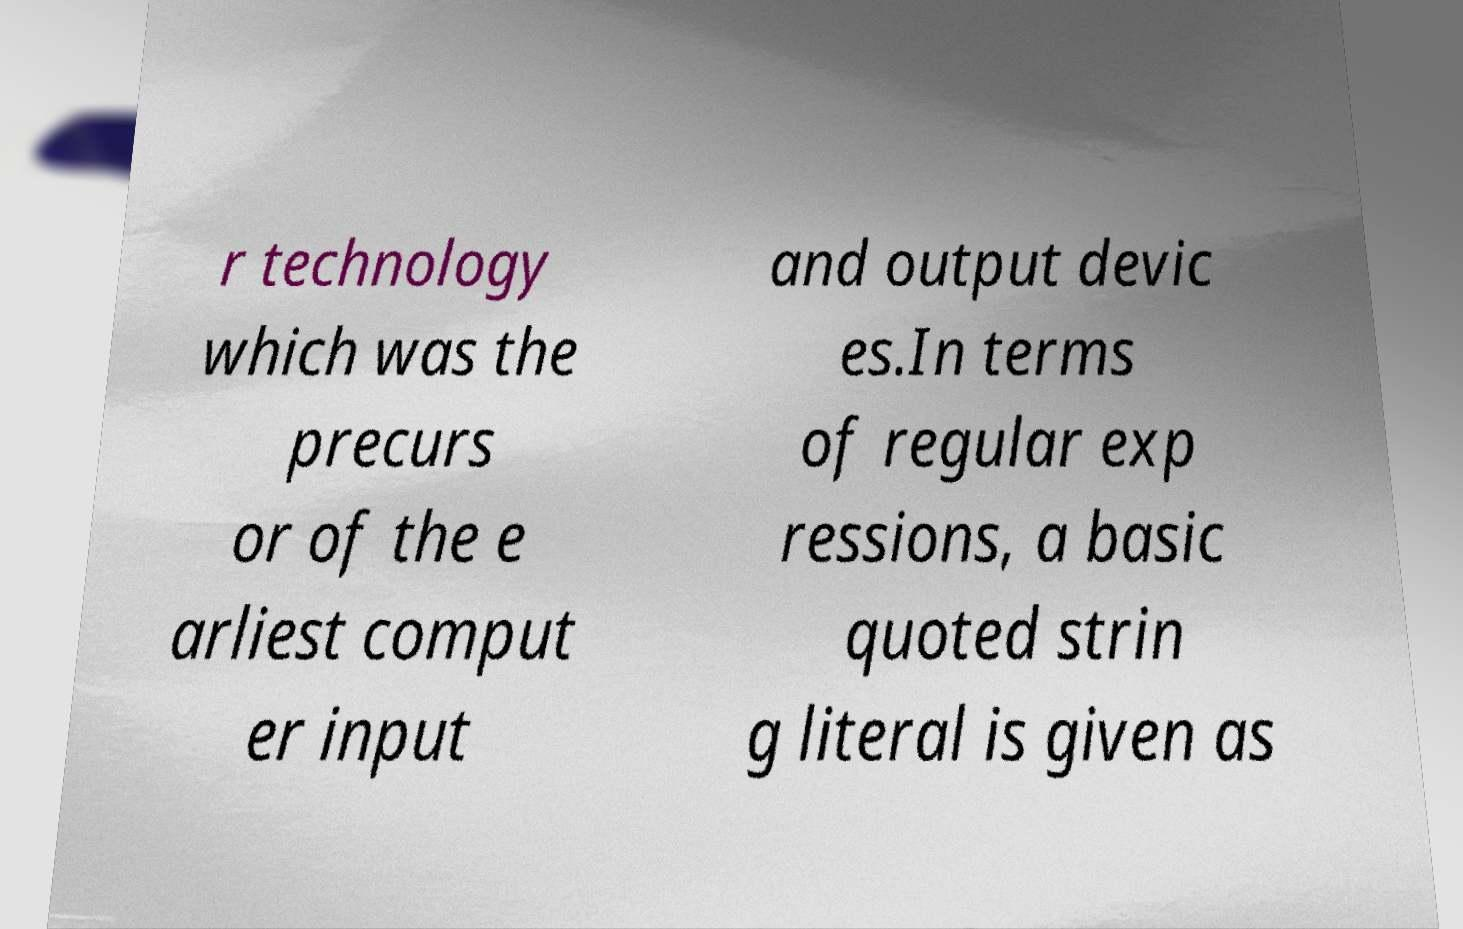Could you assist in decoding the text presented in this image and type it out clearly? r technology which was the precurs or of the e arliest comput er input and output devic es.In terms of regular exp ressions, a basic quoted strin g literal is given as 